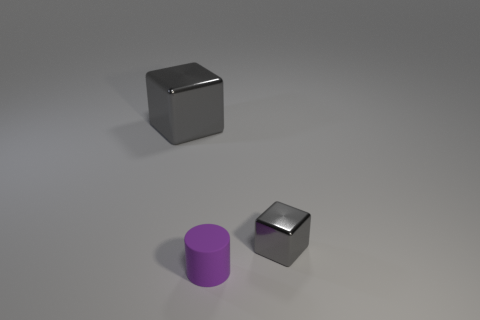Is there another rubber cylinder that has the same color as the matte cylinder?
Offer a terse response. No. There is a metal object that is the same size as the purple matte cylinder; what shape is it?
Make the answer very short. Cube. What is the color of the object behind the tiny gray block?
Provide a short and direct response. Gray. Is there a small purple rubber cylinder that is to the left of the gray block on the left side of the purple cylinder?
Keep it short and to the point. No. How many things are either metal cubes to the right of the big thing or purple things?
Provide a succinct answer. 2. What is the material of the tiny object that is on the left side of the gray cube in front of the large gray metal thing?
Offer a very short reply. Rubber. Are there the same number of blocks that are left of the small gray object and metal blocks that are on the left side of the purple cylinder?
Keep it short and to the point. Yes. What number of things are either purple rubber objects in front of the small metal cube or objects behind the tiny rubber thing?
Provide a succinct answer. 3. There is a thing that is both to the left of the tiny cube and right of the big gray metallic thing; what is its material?
Give a very brief answer. Rubber. There is a gray thing left of the cube right of the purple matte object that is in front of the big metallic object; how big is it?
Make the answer very short. Large. 